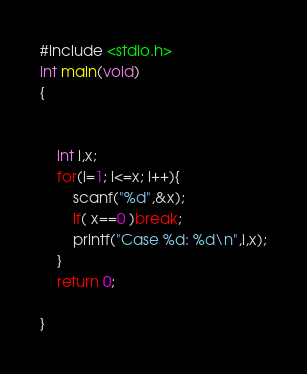Convert code to text. <code><loc_0><loc_0><loc_500><loc_500><_C_>#include <stdio.h>
int main(void)
{

    
    int i,x;
    for(i=1; i<=x; i++){
        scanf("%d",&x);
        if( x==0 )break;
        printf("Case %d: %d\n",i,x);
    }
    return 0;

}

</code> 